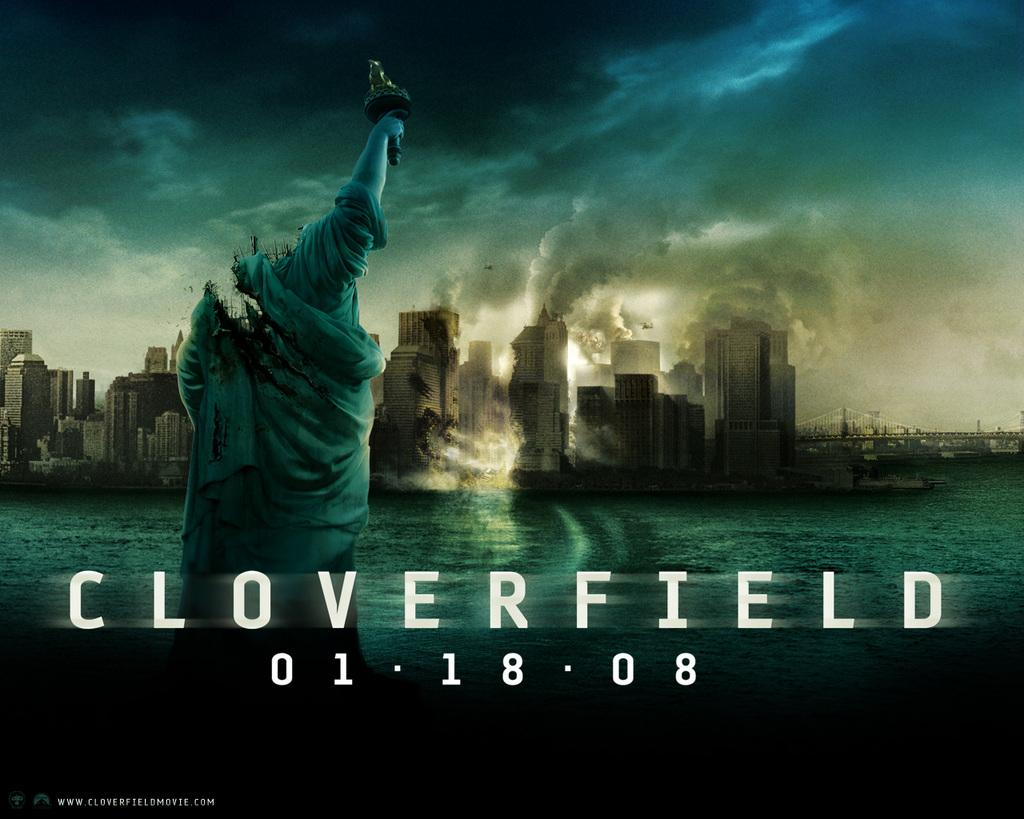<image>
Write a terse but informative summary of the picture. The poster for the movie Cloverfield shows a headless statue of liberty and a decimated New York City. 